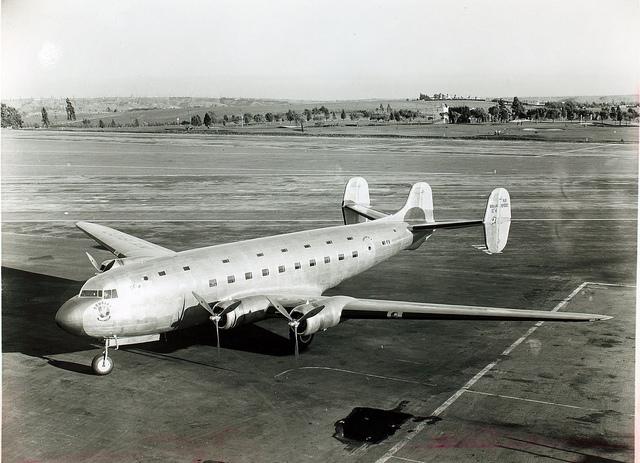Where was this photo taken?
Concise answer only. Airport. Is the plane ready for takeoff?
Give a very brief answer. Yes. Who uses this plane for travel?
Keep it brief. Military. 